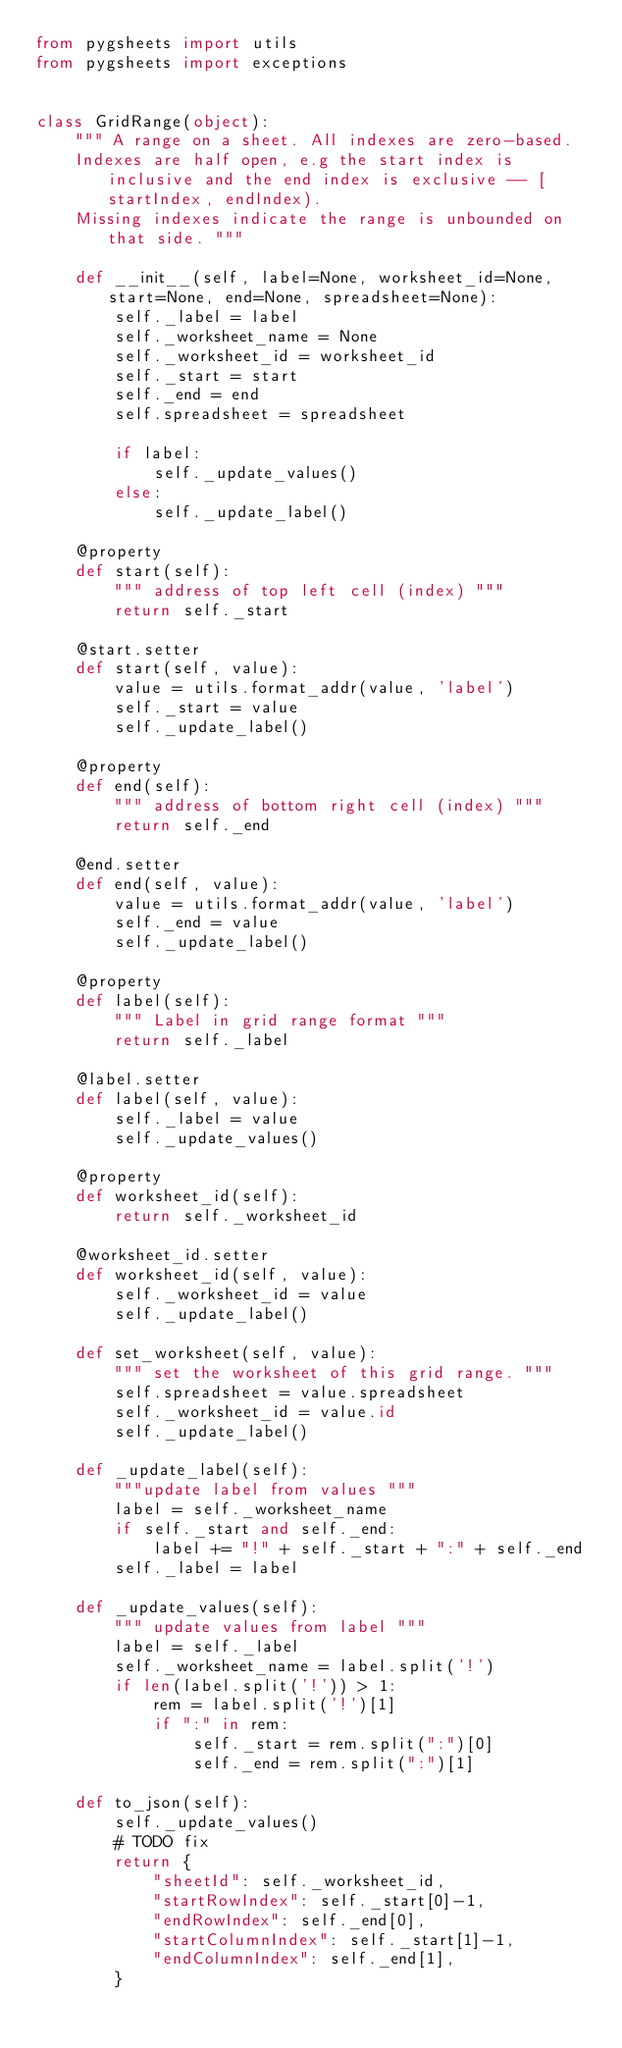Convert code to text. <code><loc_0><loc_0><loc_500><loc_500><_Python_>from pygsheets import utils
from pygsheets import exceptions


class GridRange(object):
    """ A range on a sheet. All indexes are zero-based.
    Indexes are half open, e.g the start index is inclusive and the end index is exclusive -- [startIndex, endIndex).
    Missing indexes indicate the range is unbounded on that side. """

    def __init__(self, label=None, worksheet_id=None, start=None, end=None, spreadsheet=None):
        self._label = label
        self._worksheet_name = None
        self._worksheet_id = worksheet_id
        self._start = start
        self._end = end
        self.spreadsheet = spreadsheet

        if label:
            self._update_values()
        else:
            self._update_label()

    @property
    def start(self):
        """ address of top left cell (index) """
        return self._start

    @start.setter
    def start(self, value):
        value = utils.format_addr(value, 'label')
        self._start = value
        self._update_label()

    @property
    def end(self):
        """ address of bottom right cell (index) """
        return self._end

    @end.setter
    def end(self, value):
        value = utils.format_addr(value, 'label')
        self._end = value
        self._update_label()

    @property
    def label(self):
        """ Label in grid range format """
        return self._label

    @label.setter
    def label(self, value):
        self._label = value
        self._update_values()

    @property
    def worksheet_id(self):
        return self._worksheet_id

    @worksheet_id.setter
    def worksheet_id(self, value):
        self._worksheet_id = value
        self._update_label()

    def set_worksheet(self, value):
        """ set the worksheet of this grid range. """
        self.spreadsheet = value.spreadsheet
        self._worksheet_id = value.id
        self._update_label()

    def _update_label(self):
        """update label from values """
        label = self._worksheet_name
        if self._start and self._end:
            label += "!" + self._start + ":" + self._end
        self._label = label

    def _update_values(self):
        """ update values from label """
        label = self._label
        self._worksheet_name = label.split('!')
        if len(label.split('!')) > 1:
            rem = label.split('!')[1]
            if ":" in rem:
                self._start = rem.split(":")[0]
                self._end = rem.split(":")[1]

    def to_json(self):
        self._update_values()
        # TODO fix
        return {
            "sheetId": self._worksheet_id,
            "startRowIndex": self._start[0]-1,
            "endRowIndex": self._end[0],
            "startColumnIndex": self._start[1]-1,
            "endColumnIndex": self._end[1],
        }
</code> 